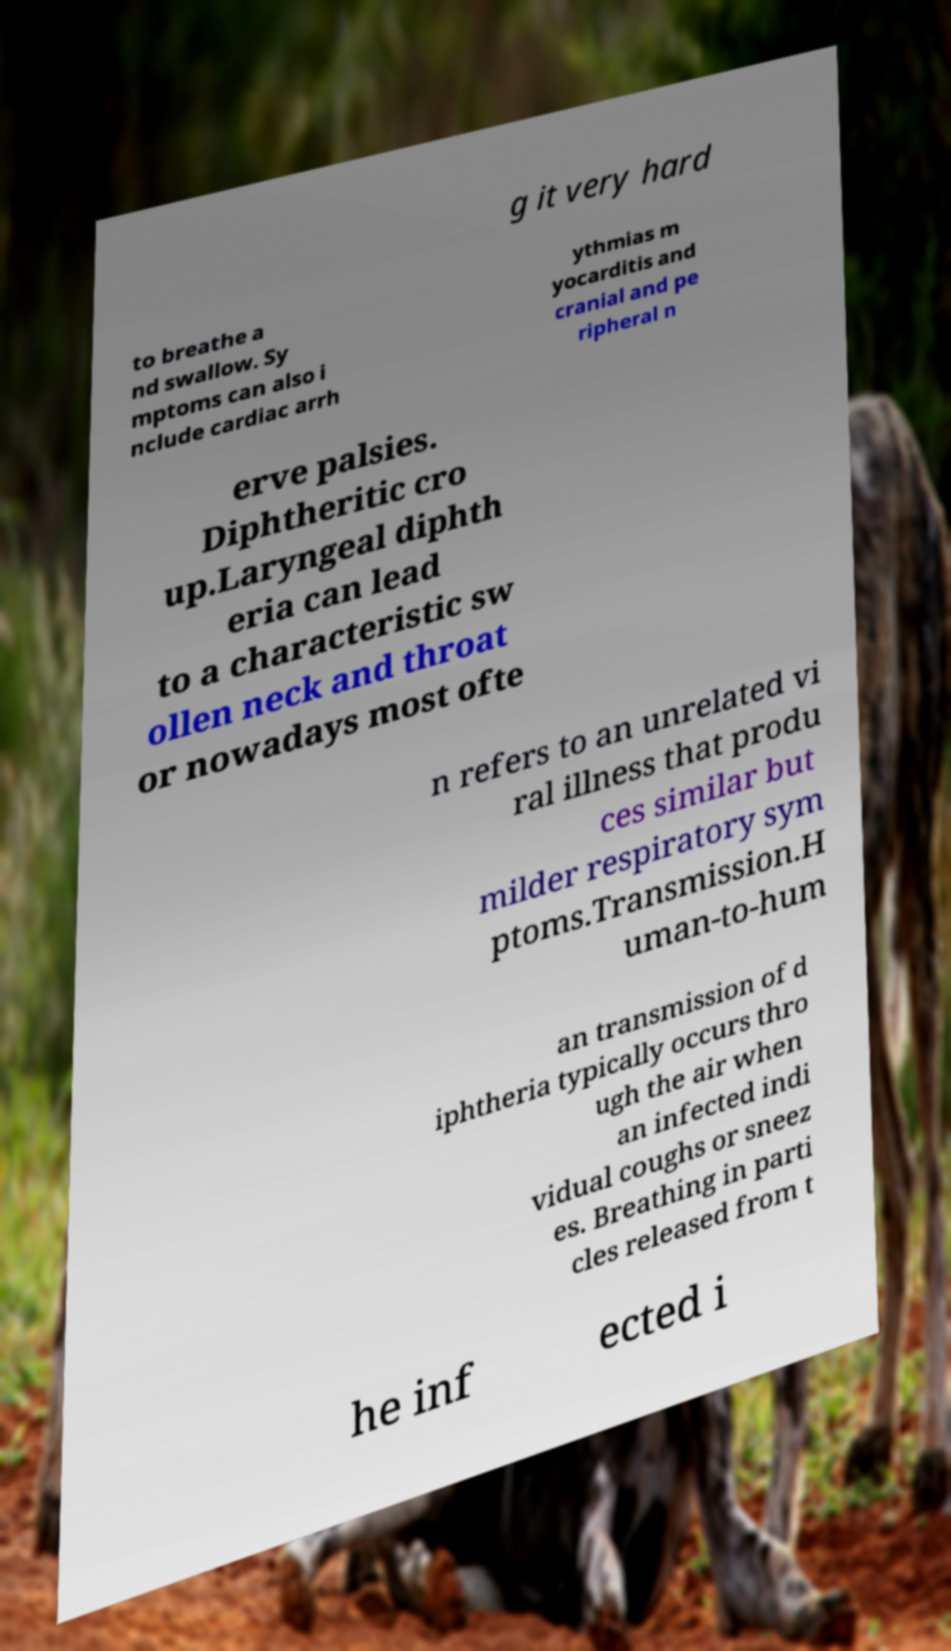There's text embedded in this image that I need extracted. Can you transcribe it verbatim? g it very hard to breathe a nd swallow. Sy mptoms can also i nclude cardiac arrh ythmias m yocarditis and cranial and pe ripheral n erve palsies. Diphtheritic cro up.Laryngeal diphth eria can lead to a characteristic sw ollen neck and throat or nowadays most ofte n refers to an unrelated vi ral illness that produ ces similar but milder respiratory sym ptoms.Transmission.H uman-to-hum an transmission of d iphtheria typically occurs thro ugh the air when an infected indi vidual coughs or sneez es. Breathing in parti cles released from t he inf ected i 